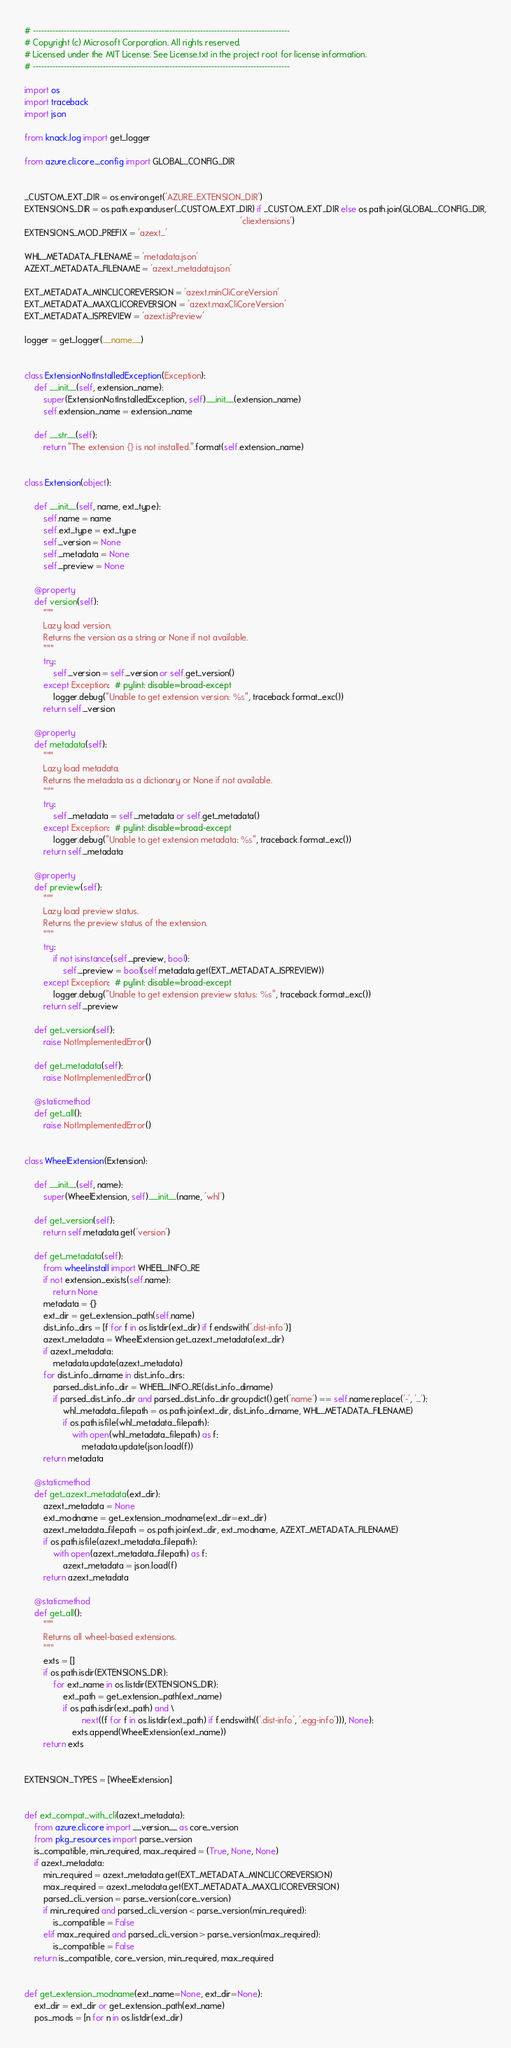<code> <loc_0><loc_0><loc_500><loc_500><_Python_># --------------------------------------------------------------------------------------------
# Copyright (c) Microsoft Corporation. All rights reserved.
# Licensed under the MIT License. See License.txt in the project root for license information.
# --------------------------------------------------------------------------------------------

import os
import traceback
import json

from knack.log import get_logger

from azure.cli.core._config import GLOBAL_CONFIG_DIR


_CUSTOM_EXT_DIR = os.environ.get('AZURE_EXTENSION_DIR')
EXTENSIONS_DIR = os.path.expanduser(_CUSTOM_EXT_DIR) if _CUSTOM_EXT_DIR else os.path.join(GLOBAL_CONFIG_DIR,
                                                                                          'cliextensions')
EXTENSIONS_MOD_PREFIX = 'azext_'

WHL_METADATA_FILENAME = 'metadata.json'
AZEXT_METADATA_FILENAME = 'azext_metadata.json'

EXT_METADATA_MINCLICOREVERSION = 'azext.minCliCoreVersion'
EXT_METADATA_MAXCLICOREVERSION = 'azext.maxCliCoreVersion'
EXT_METADATA_ISPREVIEW = 'azext.isPreview'

logger = get_logger(__name__)


class ExtensionNotInstalledException(Exception):
    def __init__(self, extension_name):
        super(ExtensionNotInstalledException, self).__init__(extension_name)
        self.extension_name = extension_name

    def __str__(self):
        return "The extension {} is not installed.".format(self.extension_name)


class Extension(object):

    def __init__(self, name, ext_type):
        self.name = name
        self.ext_type = ext_type
        self._version = None
        self._metadata = None
        self._preview = None

    @property
    def version(self):
        """
        Lazy load version.
        Returns the version as a string or None if not available.
        """
        try:
            self._version = self._version or self.get_version()
        except Exception:  # pylint: disable=broad-except
            logger.debug("Unable to get extension version: %s", traceback.format_exc())
        return self._version

    @property
    def metadata(self):
        """
        Lazy load metadata.
        Returns the metadata as a dictionary or None if not available.
        """
        try:
            self._metadata = self._metadata or self.get_metadata()
        except Exception:  # pylint: disable=broad-except
            logger.debug("Unable to get extension metadata: %s", traceback.format_exc())
        return self._metadata

    @property
    def preview(self):
        """
        Lazy load preview status.
        Returns the preview status of the extension.
        """
        try:
            if not isinstance(self._preview, bool):
                self._preview = bool(self.metadata.get(EXT_METADATA_ISPREVIEW))
        except Exception:  # pylint: disable=broad-except
            logger.debug("Unable to get extension preview status: %s", traceback.format_exc())
        return self._preview

    def get_version(self):
        raise NotImplementedError()

    def get_metadata(self):
        raise NotImplementedError()

    @staticmethod
    def get_all():
        raise NotImplementedError()


class WheelExtension(Extension):

    def __init__(self, name):
        super(WheelExtension, self).__init__(name, 'whl')

    def get_version(self):
        return self.metadata.get('version')

    def get_metadata(self):
        from wheel.install import WHEEL_INFO_RE
        if not extension_exists(self.name):
            return None
        metadata = {}
        ext_dir = get_extension_path(self.name)
        dist_info_dirs = [f for f in os.listdir(ext_dir) if f.endswith('.dist-info')]
        azext_metadata = WheelExtension.get_azext_metadata(ext_dir)
        if azext_metadata:
            metadata.update(azext_metadata)
        for dist_info_dirname in dist_info_dirs:
            parsed_dist_info_dir = WHEEL_INFO_RE(dist_info_dirname)
            if parsed_dist_info_dir and parsed_dist_info_dir.groupdict().get('name') == self.name.replace('-', '_'):
                whl_metadata_filepath = os.path.join(ext_dir, dist_info_dirname, WHL_METADATA_FILENAME)
                if os.path.isfile(whl_metadata_filepath):
                    with open(whl_metadata_filepath) as f:
                        metadata.update(json.load(f))
        return metadata

    @staticmethod
    def get_azext_metadata(ext_dir):
        azext_metadata = None
        ext_modname = get_extension_modname(ext_dir=ext_dir)
        azext_metadata_filepath = os.path.join(ext_dir, ext_modname, AZEXT_METADATA_FILENAME)
        if os.path.isfile(azext_metadata_filepath):
            with open(azext_metadata_filepath) as f:
                azext_metadata = json.load(f)
        return azext_metadata

    @staticmethod
    def get_all():
        """
        Returns all wheel-based extensions.
        """
        exts = []
        if os.path.isdir(EXTENSIONS_DIR):
            for ext_name in os.listdir(EXTENSIONS_DIR):
                ext_path = get_extension_path(ext_name)
                if os.path.isdir(ext_path) and \
                        next((f for f in os.listdir(ext_path) if f.endswith(('.dist-info', '.egg-info'))), None):
                    exts.append(WheelExtension(ext_name))
        return exts


EXTENSION_TYPES = [WheelExtension]


def ext_compat_with_cli(azext_metadata):
    from azure.cli.core import __version__ as core_version
    from pkg_resources import parse_version
    is_compatible, min_required, max_required = (True, None, None)
    if azext_metadata:
        min_required = azext_metadata.get(EXT_METADATA_MINCLICOREVERSION)
        max_required = azext_metadata.get(EXT_METADATA_MAXCLICOREVERSION)
        parsed_cli_version = parse_version(core_version)
        if min_required and parsed_cli_version < parse_version(min_required):
            is_compatible = False
        elif max_required and parsed_cli_version > parse_version(max_required):
            is_compatible = False
    return is_compatible, core_version, min_required, max_required


def get_extension_modname(ext_name=None, ext_dir=None):
    ext_dir = ext_dir or get_extension_path(ext_name)
    pos_mods = [n for n in os.listdir(ext_dir)</code> 